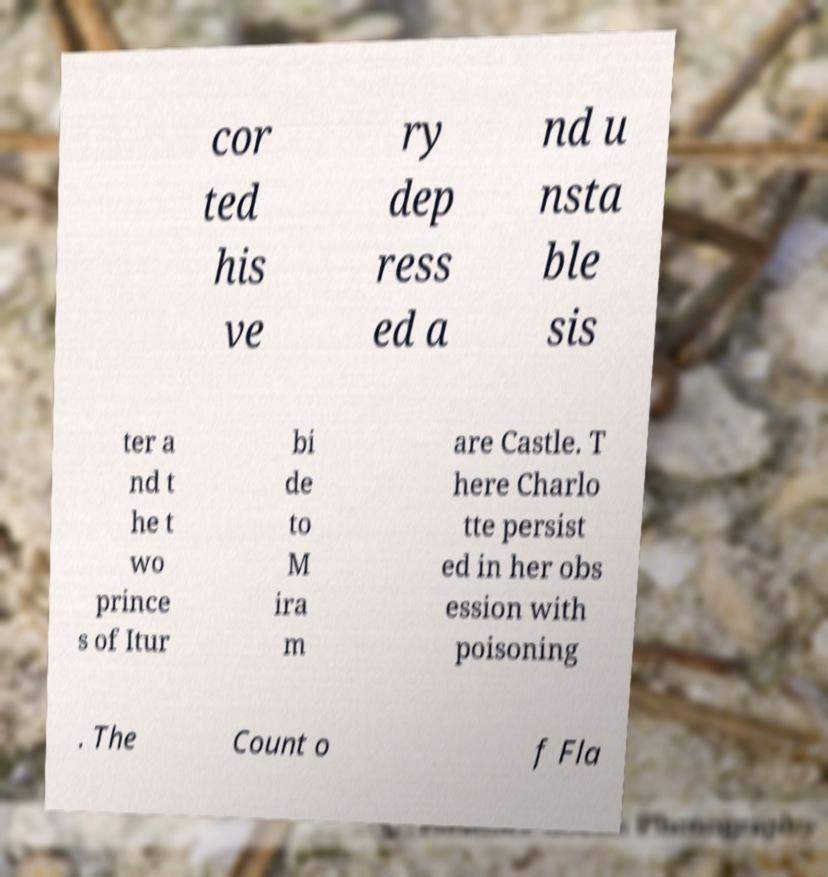Can you accurately transcribe the text from the provided image for me? cor ted his ve ry dep ress ed a nd u nsta ble sis ter a nd t he t wo prince s of Itur bi de to M ira m are Castle. T here Charlo tte persist ed in her obs ession with poisoning . The Count o f Fla 